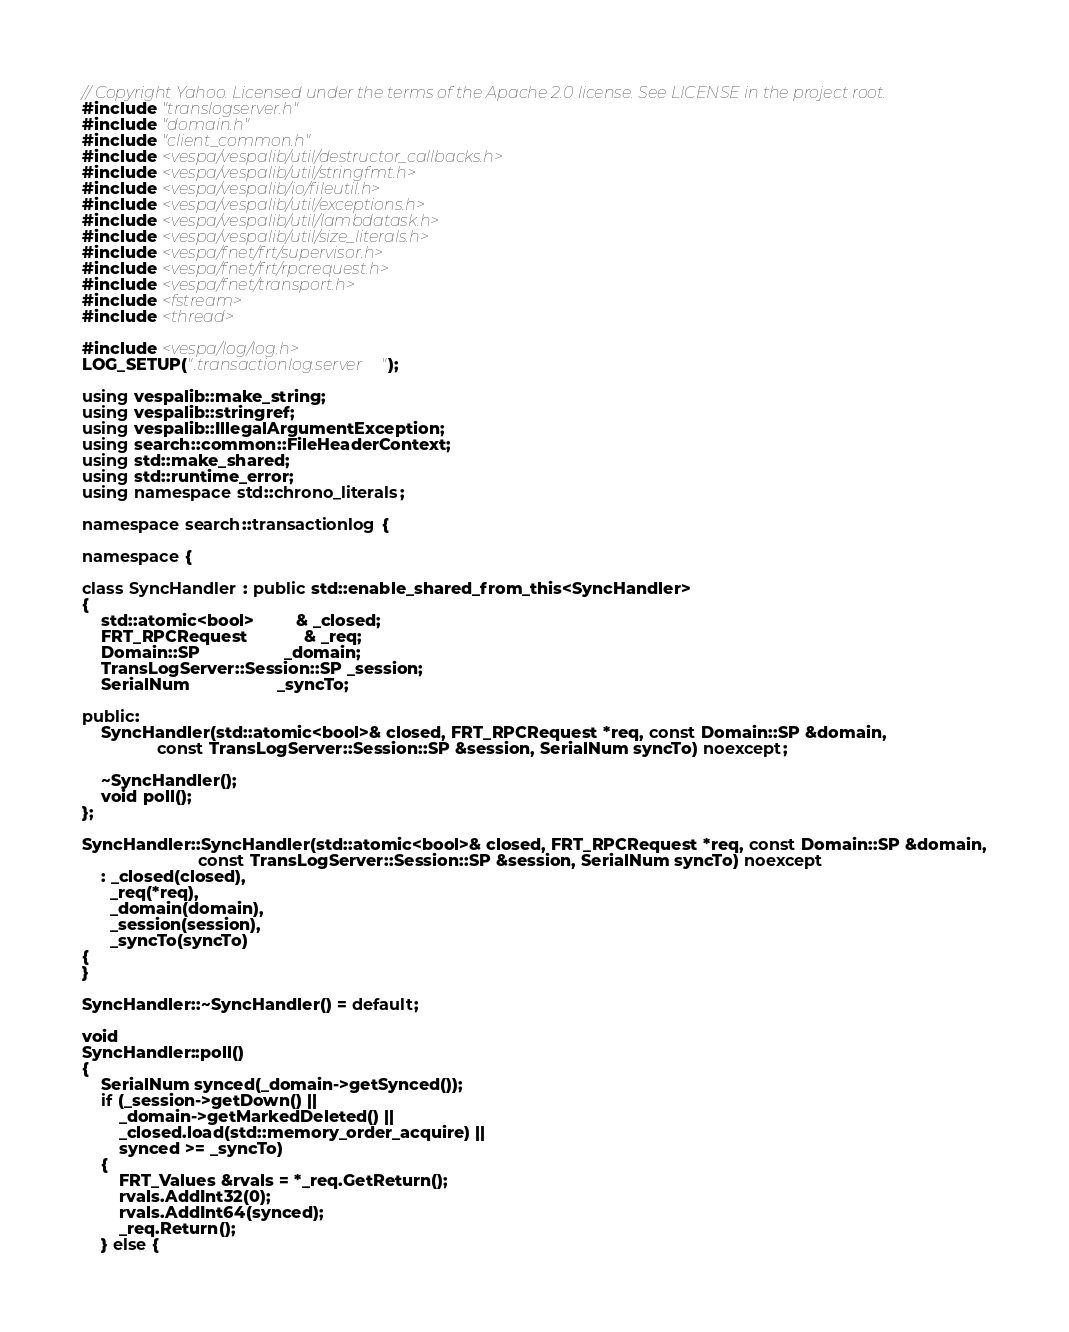Convert code to text. <code><loc_0><loc_0><loc_500><loc_500><_C++_>// Copyright Yahoo. Licensed under the terms of the Apache 2.0 license. See LICENSE in the project root.
#include "translogserver.h"
#include "domain.h"
#include "client_common.h"
#include <vespa/vespalib/util/destructor_callbacks.h>
#include <vespa/vespalib/util/stringfmt.h>
#include <vespa/vespalib/io/fileutil.h>
#include <vespa/vespalib/util/exceptions.h>
#include <vespa/vespalib/util/lambdatask.h>
#include <vespa/vespalib/util/size_literals.h>
#include <vespa/fnet/frt/supervisor.h>
#include <vespa/fnet/frt/rpcrequest.h>
#include <vespa/fnet/transport.h>
#include <fstream>
#include <thread>

#include <vespa/log/log.h>
LOG_SETUP(".transactionlog.server");

using vespalib::make_string;
using vespalib::stringref;
using vespalib::IllegalArgumentException;
using search::common::FileHeaderContext;
using std::make_shared;
using std::runtime_error;
using namespace std::chrono_literals;

namespace search::transactionlog {

namespace {

class SyncHandler : public std::enable_shared_from_this<SyncHandler>
{
    std::atomic<bool>         & _closed;
    FRT_RPCRequest            & _req;
    Domain::SP                  _domain;
    TransLogServer::Session::SP _session; 
    SerialNum                   _syncTo;
    
public:
    SyncHandler(std::atomic<bool>& closed, FRT_RPCRequest *req, const Domain::SP &domain,
                const TransLogServer::Session::SP &session, SerialNum syncTo) noexcept;

    ~SyncHandler();
    void poll();
};

SyncHandler::SyncHandler(std::atomic<bool>& closed, FRT_RPCRequest *req, const Domain::SP &domain,
                         const TransLogServer::Session::SP &session, SerialNum syncTo) noexcept
    : _closed(closed),
      _req(*req),
      _domain(domain),
      _session(session),
      _syncTo(syncTo)
{
}

SyncHandler::~SyncHandler() = default;

void
SyncHandler::poll()
{
    SerialNum synced(_domain->getSynced());
    if (_session->getDown() ||
        _domain->getMarkedDeleted() ||
        _closed.load(std::memory_order_acquire) ||
        synced >= _syncTo)
    {
        FRT_Values &rvals = *_req.GetReturn();
        rvals.AddInt32(0);
        rvals.AddInt64(synced);
        _req.Return();
    } else {</code> 